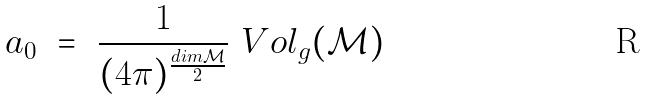Convert formula to latex. <formula><loc_0><loc_0><loc_500><loc_500>a _ { 0 } \ = \ \frac { 1 } { ( 4 \pi ) ^ { \frac { d i m \mathcal { M } } { 2 } } } \ V o l _ { g } ( \mathcal { M } )</formula> 